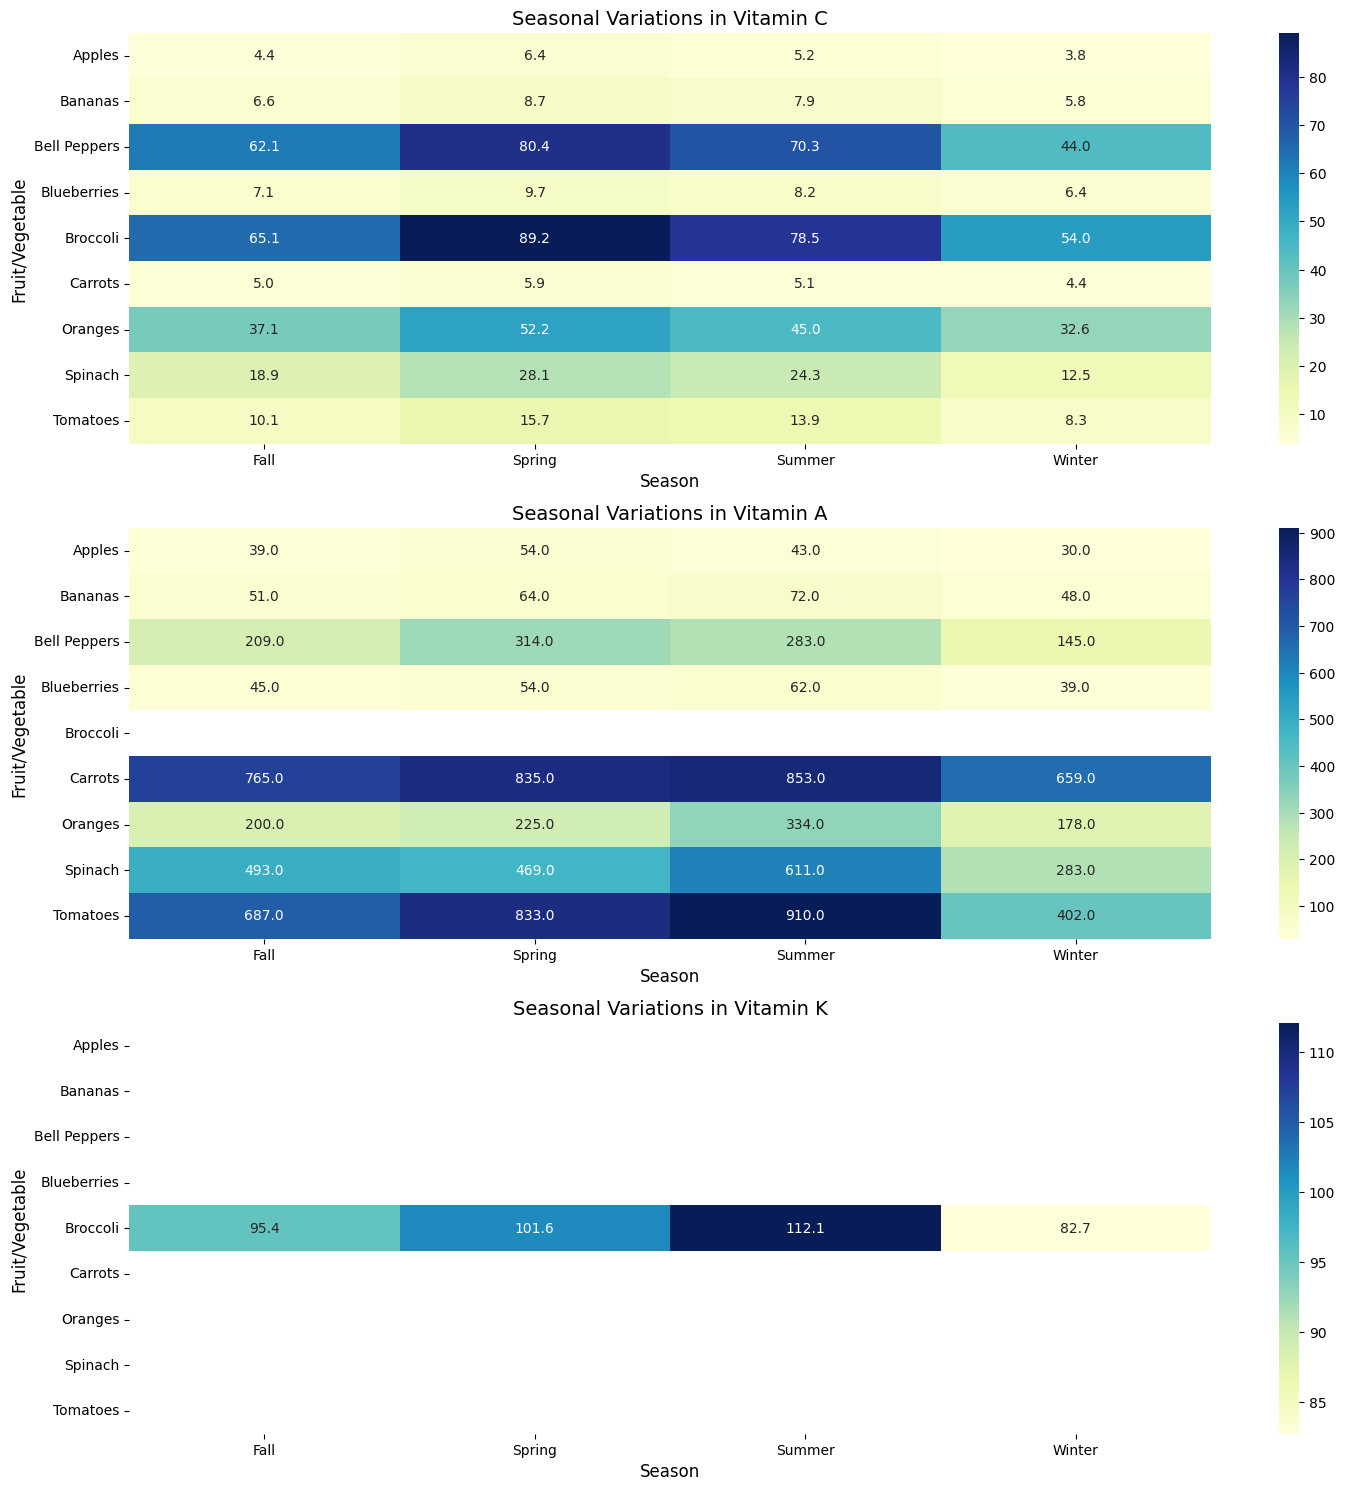Which season has the highest Vitamin C content in Spinach? Look for the highest value in the row for Spinach in the heatmap representing Vitamin C. The highest value is 28.1 in Spring.
Answer: Spring How does the Vitamin A content in Tomatoes compare between Summer and Winter? Compare the values for Vitamin A in Tomatoes for Summer and Winter. Summer has a value of 910, and Winter has a value of 402. Summer's value is higher.
Answer: Summer > Winter Which fruit or vegetable has the lowest Vitamin C content in Winter? Locate the row with the lowest value for Winter in the heatmap representing Vitamin C. Apples have the lowest value at 3.8.
Answer: Apples What's the average Vitamin C content across all seasons for Broccoli? Add the values of Vitamin C for Broccoli across all seasons and divide by the number of seasons. (89.2 + 78.5 + 65.1 + 54.0) / 4 = 71.7
Answer: 71.7 Which Vitamin shows the most significant seasonal variation in Bell Peppers? Look for the Vitamin in Bell Peppers that has the most considerable difference between the highest and lowest values across seasons. For Vitamin C, the difference is (80.4 - 44.0) = 36.4, and for Vitamin A, it is (314 - 145) = 169. Vitamin A shows the most significant variation.
Answer: Vitamin A During which season do Blueberries have the highest content of Vitamin C? Locate the highest value for Vitamin C in Blueberries across the seasons in the heatmap. The highest value is in Spring at 9.7.
Answer: Spring Compare the Vitamin K content in Broccoli between Fall and Winter. Which is higher? Check the values for Vitamin K in Broccoli for Fall and Winter. Fall has a value of 95.4, and Winter has 82.7. Fall's value is higher.
Answer: Fall What is the combined Vitamin A content for Carrots in Spring and Summer? Add the values of Vitamin A in Carrots for Spring and Summer. 835 (Spring) + 853 (Summer) = 1688.
Answer: 1688 Is the Vitamin C content in Oranges higher in Spring or Fall? Compare the Vitamin C values for Oranges in Spring and Fall. Spring has a value of 52.2, and Fall has a value of 37.1. Spring's value is higher.
Answer: Spring 